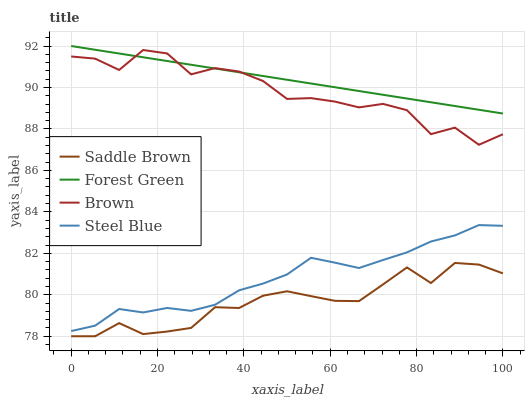Does Saddle Brown have the minimum area under the curve?
Answer yes or no. Yes. Does Forest Green have the maximum area under the curve?
Answer yes or no. Yes. Does Forest Green have the minimum area under the curve?
Answer yes or no. No. Does Saddle Brown have the maximum area under the curve?
Answer yes or no. No. Is Forest Green the smoothest?
Answer yes or no. Yes. Is Brown the roughest?
Answer yes or no. Yes. Is Saddle Brown the smoothest?
Answer yes or no. No. Is Saddle Brown the roughest?
Answer yes or no. No. Does Forest Green have the lowest value?
Answer yes or no. No. Does Forest Green have the highest value?
Answer yes or no. Yes. Does Saddle Brown have the highest value?
Answer yes or no. No. Is Saddle Brown less than Forest Green?
Answer yes or no. Yes. Is Steel Blue greater than Saddle Brown?
Answer yes or no. Yes. Does Forest Green intersect Brown?
Answer yes or no. Yes. Is Forest Green less than Brown?
Answer yes or no. No. Is Forest Green greater than Brown?
Answer yes or no. No. Does Saddle Brown intersect Forest Green?
Answer yes or no. No. 